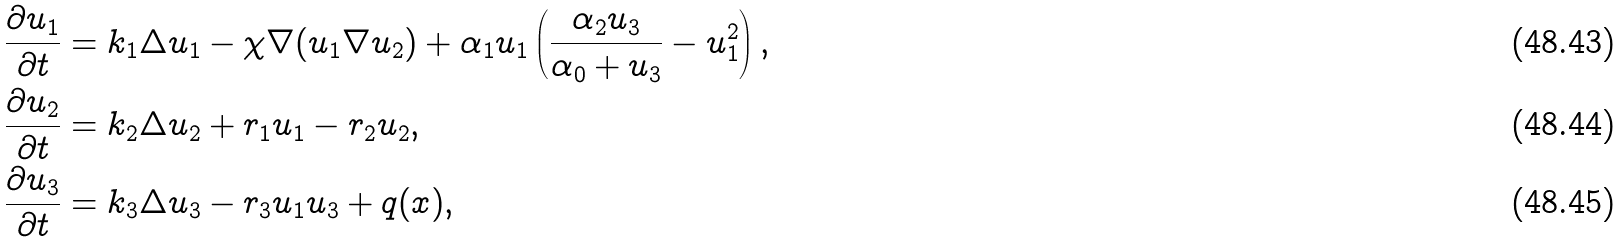<formula> <loc_0><loc_0><loc_500><loc_500>& \frac { \partial u _ { 1 } } { \partial t } = k _ { 1 } \Delta u _ { 1 } - \chi \nabla ( u _ { 1 } \nabla u _ { 2 } ) + \alpha _ { 1 } u _ { 1 } \left ( \frac { \alpha _ { 2 } u _ { 3 } } { \alpha _ { 0 } + u _ { 3 } } - u ^ { 2 } _ { 1 } \right ) , \\ & \frac { \partial u _ { 2 } } { \partial t } = k _ { 2 } \Delta u _ { 2 } + r _ { 1 } u _ { 1 } - r _ { 2 } u _ { 2 } , \\ & \frac { \partial u _ { 3 } } { \partial t } = k _ { 3 } \Delta u _ { 3 } - r _ { 3 } u _ { 1 } u _ { 3 } + q ( x ) ,</formula> 